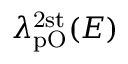Convert formula to latex. <formula><loc_0><loc_0><loc_500><loc_500>\lambda _ { p O } ^ { 2 s t } ( E )</formula> 